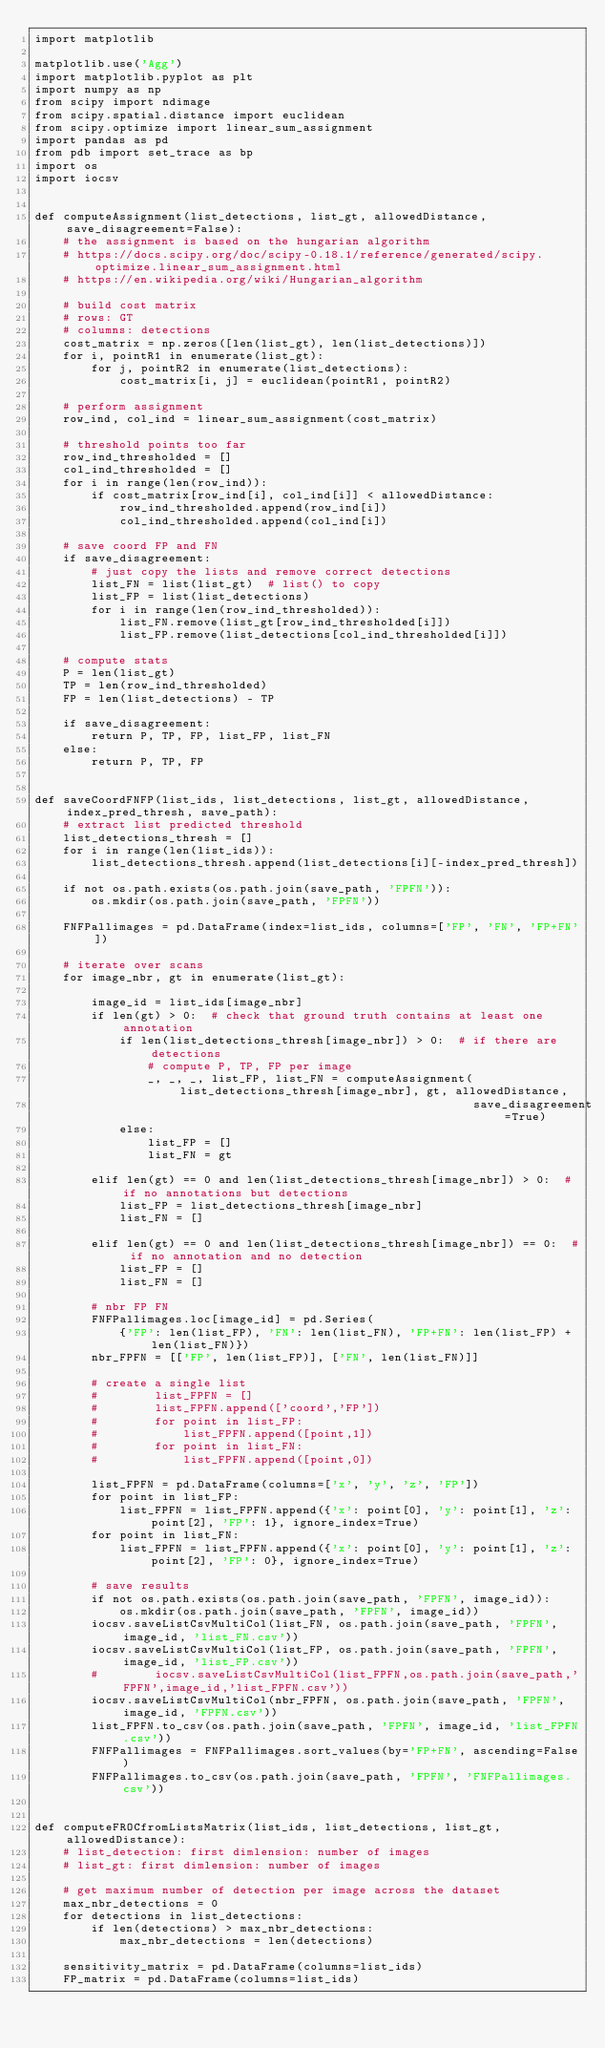<code> <loc_0><loc_0><loc_500><loc_500><_Python_>import matplotlib

matplotlib.use('Agg')
import matplotlib.pyplot as plt
import numpy as np
from scipy import ndimage
from scipy.spatial.distance import euclidean
from scipy.optimize import linear_sum_assignment
import pandas as pd
from pdb import set_trace as bp
import os
import iocsv


def computeAssignment(list_detections, list_gt, allowedDistance, save_disagreement=False):
    # the assignment is based on the hungarian algorithm
    # https://docs.scipy.org/doc/scipy-0.18.1/reference/generated/scipy.optimize.linear_sum_assignment.html
    # https://en.wikipedia.org/wiki/Hungarian_algorithm

    # build cost matrix
    # rows: GT
    # columns: detections
    cost_matrix = np.zeros([len(list_gt), len(list_detections)])
    for i, pointR1 in enumerate(list_gt):
        for j, pointR2 in enumerate(list_detections):
            cost_matrix[i, j] = euclidean(pointR1, pointR2)

    # perform assignment
    row_ind, col_ind = linear_sum_assignment(cost_matrix)

    # threshold points too far
    row_ind_thresholded = []
    col_ind_thresholded = []
    for i in range(len(row_ind)):
        if cost_matrix[row_ind[i], col_ind[i]] < allowedDistance:
            row_ind_thresholded.append(row_ind[i])
            col_ind_thresholded.append(col_ind[i])

    # save coord FP and FN
    if save_disagreement:
        # just copy the lists and remove correct detections
        list_FN = list(list_gt)  # list() to copy
        list_FP = list(list_detections)
        for i in range(len(row_ind_thresholded)):
            list_FN.remove(list_gt[row_ind_thresholded[i]])
            list_FP.remove(list_detections[col_ind_thresholded[i]])

    # compute stats
    P = len(list_gt)
    TP = len(row_ind_thresholded)
    FP = len(list_detections) - TP

    if save_disagreement:
        return P, TP, FP, list_FP, list_FN
    else:
        return P, TP, FP


def saveCoordFNFP(list_ids, list_detections, list_gt, allowedDistance, index_pred_thresh, save_path):
    # extract list predicted threshold
    list_detections_thresh = []
    for i in range(len(list_ids)):
        list_detections_thresh.append(list_detections[i][-index_pred_thresh])

    if not os.path.exists(os.path.join(save_path, 'FPFN')):
        os.mkdir(os.path.join(save_path, 'FPFN'))

    FNFPallimages = pd.DataFrame(index=list_ids, columns=['FP', 'FN', 'FP+FN'])

    # iterate over scans
    for image_nbr, gt in enumerate(list_gt):

        image_id = list_ids[image_nbr]
        if len(gt) > 0:  # check that ground truth contains at least one annotation
            if len(list_detections_thresh[image_nbr]) > 0:  # if there are detections
                # compute P, TP, FP per image
                _, _, _, list_FP, list_FN = computeAssignment(list_detections_thresh[image_nbr], gt, allowedDistance,
                                                              save_disagreement=True)
            else:
                list_FP = []
                list_FN = gt

        elif len(gt) == 0 and len(list_detections_thresh[image_nbr]) > 0:  # if no annotations but detections
            list_FP = list_detections_thresh[image_nbr]
            list_FN = []

        elif len(gt) == 0 and len(list_detections_thresh[image_nbr]) == 0:  # if no annotation and no detection
            list_FP = []
            list_FN = []

        # nbr FP FN
        FNFPallimages.loc[image_id] = pd.Series(
            {'FP': len(list_FP), 'FN': len(list_FN), 'FP+FN': len(list_FP) + len(list_FN)})
        nbr_FPFN = [['FP', len(list_FP)], ['FN', len(list_FN)]]

        # create a single list
        #        list_FPFN = []
        #        list_FPFN.append(['coord','FP'])
        #        for point in list_FP:
        #            list_FPFN.append([point,1])
        #        for point in list_FN:
        #            list_FPFN.append([point,0])

        list_FPFN = pd.DataFrame(columns=['x', 'y', 'z', 'FP'])
        for point in list_FP:
            list_FPFN = list_FPFN.append({'x': point[0], 'y': point[1], 'z': point[2], 'FP': 1}, ignore_index=True)
        for point in list_FN:
            list_FPFN = list_FPFN.append({'x': point[0], 'y': point[1], 'z': point[2], 'FP': 0}, ignore_index=True)

        # save results
        if not os.path.exists(os.path.join(save_path, 'FPFN', image_id)):
            os.mkdir(os.path.join(save_path, 'FPFN', image_id))
        iocsv.saveListCsvMultiCol(list_FN, os.path.join(save_path, 'FPFN', image_id, 'list_FN.csv'))
        iocsv.saveListCsvMultiCol(list_FP, os.path.join(save_path, 'FPFN', image_id, 'list_FP.csv'))
        #        iocsv.saveListCsvMultiCol(list_FPFN,os.path.join(save_path,'FPFN',image_id,'list_FPFN.csv'))
        iocsv.saveListCsvMultiCol(nbr_FPFN, os.path.join(save_path, 'FPFN', image_id, 'FPFN.csv'))
        list_FPFN.to_csv(os.path.join(save_path, 'FPFN', image_id, 'list_FPFN.csv'))
        FNFPallimages = FNFPallimages.sort_values(by='FP+FN', ascending=False)
        FNFPallimages.to_csv(os.path.join(save_path, 'FPFN', 'FNFPallimages.csv'))


def computeFROCfromListsMatrix(list_ids, list_detections, list_gt, allowedDistance):
    # list_detection: first dimlension: number of images
    # list_gt: first dimlension: number of images

    # get maximum number of detection per image across the dataset
    max_nbr_detections = 0
    for detections in list_detections:
        if len(detections) > max_nbr_detections:
            max_nbr_detections = len(detections)

    sensitivity_matrix = pd.DataFrame(columns=list_ids)
    FP_matrix = pd.DataFrame(columns=list_ids)
</code> 